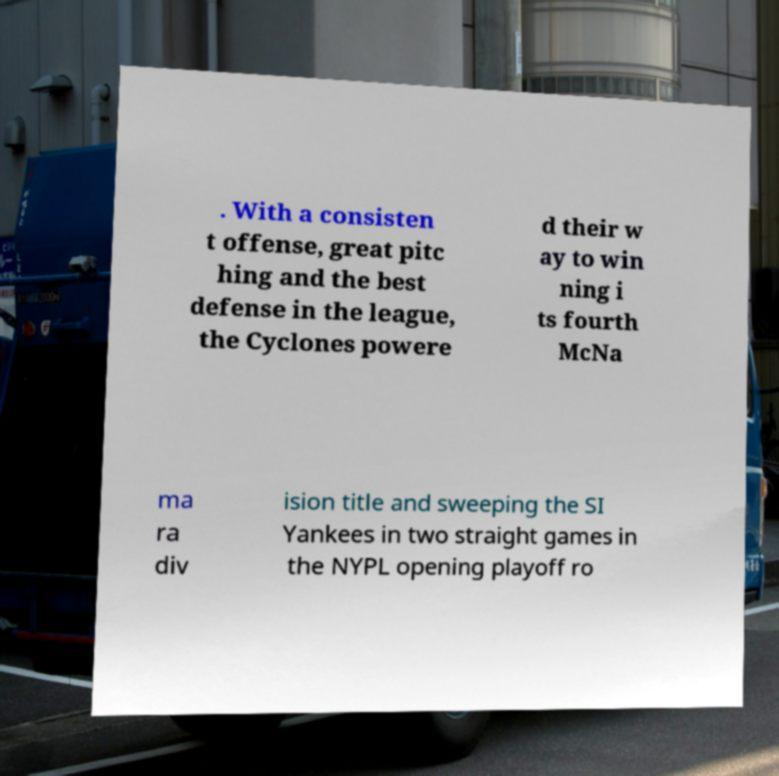What messages or text are displayed in this image? I need them in a readable, typed format. . With a consisten t offense, great pitc hing and the best defense in the league, the Cyclones powere d their w ay to win ning i ts fourth McNa ma ra div ision title and sweeping the SI Yankees in two straight games in the NYPL opening playoff ro 